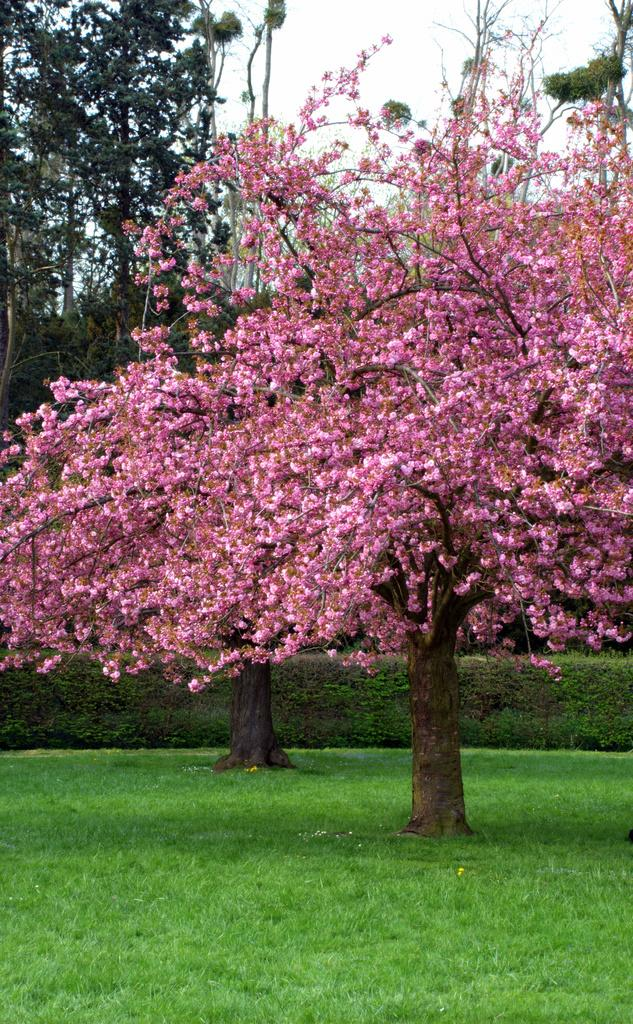What type of tree is featured in the image? There is a tree with pink flowers in the image. Where is the tree located? The tree is located in a garden. What can be seen behind the tree in the image? There are many plants and trees visible behind the tree. What type of breakfast is being prepared in the image? There is no breakfast preparation visible in the image; it features a tree with pink flowers in a garden. 